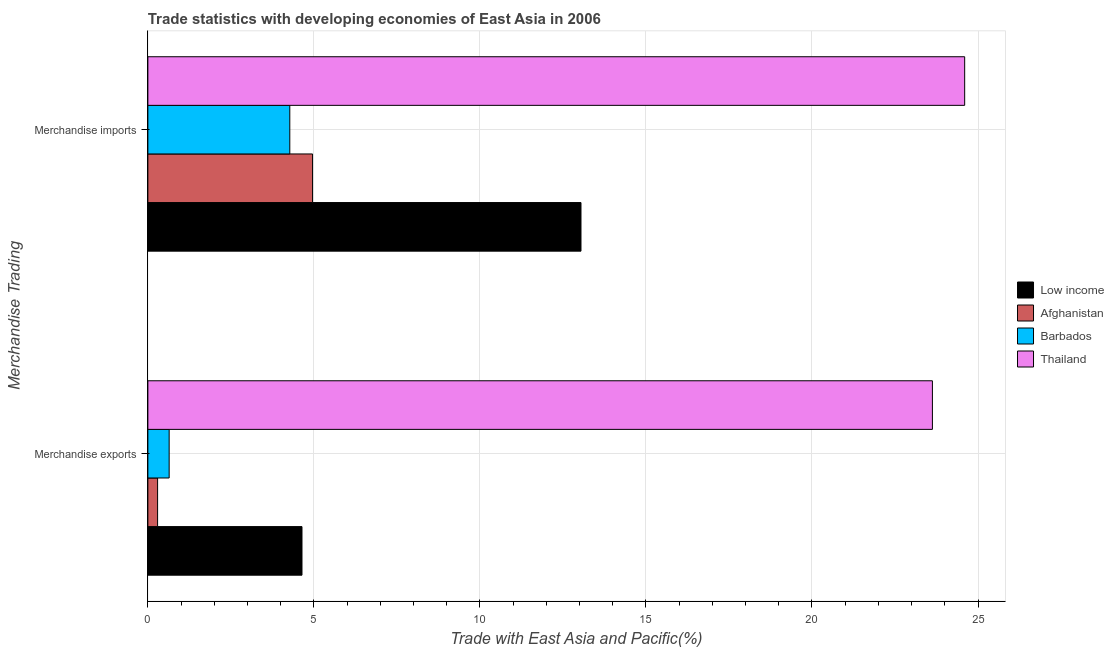Are the number of bars per tick equal to the number of legend labels?
Ensure brevity in your answer.  Yes. What is the merchandise imports in Afghanistan?
Your response must be concise. 4.96. Across all countries, what is the maximum merchandise exports?
Your response must be concise. 23.63. Across all countries, what is the minimum merchandise exports?
Your answer should be very brief. 0.29. In which country was the merchandise exports maximum?
Offer a very short reply. Thailand. In which country was the merchandise imports minimum?
Keep it short and to the point. Barbados. What is the total merchandise exports in the graph?
Provide a succinct answer. 29.2. What is the difference between the merchandise exports in Barbados and that in Low income?
Your response must be concise. -4. What is the difference between the merchandise exports in Low income and the merchandise imports in Afghanistan?
Provide a short and direct response. -0.32. What is the average merchandise imports per country?
Provide a succinct answer. 11.72. What is the difference between the merchandise imports and merchandise exports in Low income?
Provide a short and direct response. 8.4. What is the ratio of the merchandise imports in Afghanistan to that in Thailand?
Your answer should be compact. 0.2. Is the merchandise imports in Afghanistan less than that in Thailand?
Your answer should be very brief. Yes. What does the 1st bar from the top in Merchandise exports represents?
Your response must be concise. Thailand. What does the 1st bar from the bottom in Merchandise exports represents?
Offer a very short reply. Low income. Are the values on the major ticks of X-axis written in scientific E-notation?
Your answer should be compact. No. How many legend labels are there?
Your response must be concise. 4. What is the title of the graph?
Offer a very short reply. Trade statistics with developing economies of East Asia in 2006. Does "Ethiopia" appear as one of the legend labels in the graph?
Your answer should be compact. No. What is the label or title of the X-axis?
Your answer should be compact. Trade with East Asia and Pacific(%). What is the label or title of the Y-axis?
Give a very brief answer. Merchandise Trading. What is the Trade with East Asia and Pacific(%) in Low income in Merchandise exports?
Your response must be concise. 4.64. What is the Trade with East Asia and Pacific(%) of Afghanistan in Merchandise exports?
Offer a very short reply. 0.29. What is the Trade with East Asia and Pacific(%) in Barbados in Merchandise exports?
Your response must be concise. 0.64. What is the Trade with East Asia and Pacific(%) of Thailand in Merchandise exports?
Offer a terse response. 23.63. What is the Trade with East Asia and Pacific(%) in Low income in Merchandise imports?
Offer a very short reply. 13.04. What is the Trade with East Asia and Pacific(%) of Afghanistan in Merchandise imports?
Give a very brief answer. 4.96. What is the Trade with East Asia and Pacific(%) of Barbados in Merchandise imports?
Make the answer very short. 4.27. What is the Trade with East Asia and Pacific(%) of Thailand in Merchandise imports?
Offer a terse response. 24.6. Across all Merchandise Trading, what is the maximum Trade with East Asia and Pacific(%) of Low income?
Give a very brief answer. 13.04. Across all Merchandise Trading, what is the maximum Trade with East Asia and Pacific(%) in Afghanistan?
Your answer should be compact. 4.96. Across all Merchandise Trading, what is the maximum Trade with East Asia and Pacific(%) of Barbados?
Give a very brief answer. 4.27. Across all Merchandise Trading, what is the maximum Trade with East Asia and Pacific(%) in Thailand?
Offer a very short reply. 24.6. Across all Merchandise Trading, what is the minimum Trade with East Asia and Pacific(%) of Low income?
Your answer should be compact. 4.64. Across all Merchandise Trading, what is the minimum Trade with East Asia and Pacific(%) in Afghanistan?
Keep it short and to the point. 0.29. Across all Merchandise Trading, what is the minimum Trade with East Asia and Pacific(%) in Barbados?
Your answer should be very brief. 0.64. Across all Merchandise Trading, what is the minimum Trade with East Asia and Pacific(%) in Thailand?
Give a very brief answer. 23.63. What is the total Trade with East Asia and Pacific(%) in Low income in the graph?
Your answer should be very brief. 17.69. What is the total Trade with East Asia and Pacific(%) in Afghanistan in the graph?
Keep it short and to the point. 5.25. What is the total Trade with East Asia and Pacific(%) in Barbados in the graph?
Provide a succinct answer. 4.92. What is the total Trade with East Asia and Pacific(%) of Thailand in the graph?
Ensure brevity in your answer.  48.23. What is the difference between the Trade with East Asia and Pacific(%) in Low income in Merchandise exports and that in Merchandise imports?
Your answer should be very brief. -8.4. What is the difference between the Trade with East Asia and Pacific(%) of Afghanistan in Merchandise exports and that in Merchandise imports?
Offer a terse response. -4.67. What is the difference between the Trade with East Asia and Pacific(%) of Barbados in Merchandise exports and that in Merchandise imports?
Provide a succinct answer. -3.63. What is the difference between the Trade with East Asia and Pacific(%) of Thailand in Merchandise exports and that in Merchandise imports?
Give a very brief answer. -0.97. What is the difference between the Trade with East Asia and Pacific(%) in Low income in Merchandise exports and the Trade with East Asia and Pacific(%) in Afghanistan in Merchandise imports?
Provide a succinct answer. -0.32. What is the difference between the Trade with East Asia and Pacific(%) of Low income in Merchandise exports and the Trade with East Asia and Pacific(%) of Barbados in Merchandise imports?
Offer a terse response. 0.37. What is the difference between the Trade with East Asia and Pacific(%) of Low income in Merchandise exports and the Trade with East Asia and Pacific(%) of Thailand in Merchandise imports?
Offer a terse response. -19.96. What is the difference between the Trade with East Asia and Pacific(%) in Afghanistan in Merchandise exports and the Trade with East Asia and Pacific(%) in Barbados in Merchandise imports?
Offer a terse response. -3.98. What is the difference between the Trade with East Asia and Pacific(%) in Afghanistan in Merchandise exports and the Trade with East Asia and Pacific(%) in Thailand in Merchandise imports?
Keep it short and to the point. -24.31. What is the difference between the Trade with East Asia and Pacific(%) of Barbados in Merchandise exports and the Trade with East Asia and Pacific(%) of Thailand in Merchandise imports?
Offer a terse response. -23.96. What is the average Trade with East Asia and Pacific(%) of Low income per Merchandise Trading?
Your answer should be compact. 8.84. What is the average Trade with East Asia and Pacific(%) in Afghanistan per Merchandise Trading?
Your answer should be compact. 2.63. What is the average Trade with East Asia and Pacific(%) of Barbados per Merchandise Trading?
Your answer should be compact. 2.46. What is the average Trade with East Asia and Pacific(%) of Thailand per Merchandise Trading?
Your response must be concise. 24.11. What is the difference between the Trade with East Asia and Pacific(%) of Low income and Trade with East Asia and Pacific(%) of Afghanistan in Merchandise exports?
Offer a terse response. 4.35. What is the difference between the Trade with East Asia and Pacific(%) of Low income and Trade with East Asia and Pacific(%) of Barbados in Merchandise exports?
Offer a very short reply. 4. What is the difference between the Trade with East Asia and Pacific(%) of Low income and Trade with East Asia and Pacific(%) of Thailand in Merchandise exports?
Your response must be concise. -18.99. What is the difference between the Trade with East Asia and Pacific(%) of Afghanistan and Trade with East Asia and Pacific(%) of Barbados in Merchandise exports?
Offer a terse response. -0.35. What is the difference between the Trade with East Asia and Pacific(%) of Afghanistan and Trade with East Asia and Pacific(%) of Thailand in Merchandise exports?
Offer a terse response. -23.33. What is the difference between the Trade with East Asia and Pacific(%) of Barbados and Trade with East Asia and Pacific(%) of Thailand in Merchandise exports?
Your response must be concise. -22.99. What is the difference between the Trade with East Asia and Pacific(%) of Low income and Trade with East Asia and Pacific(%) of Afghanistan in Merchandise imports?
Your response must be concise. 8.08. What is the difference between the Trade with East Asia and Pacific(%) in Low income and Trade with East Asia and Pacific(%) in Barbados in Merchandise imports?
Your response must be concise. 8.77. What is the difference between the Trade with East Asia and Pacific(%) of Low income and Trade with East Asia and Pacific(%) of Thailand in Merchandise imports?
Give a very brief answer. -11.55. What is the difference between the Trade with East Asia and Pacific(%) in Afghanistan and Trade with East Asia and Pacific(%) in Barbados in Merchandise imports?
Ensure brevity in your answer.  0.68. What is the difference between the Trade with East Asia and Pacific(%) of Afghanistan and Trade with East Asia and Pacific(%) of Thailand in Merchandise imports?
Offer a terse response. -19.64. What is the difference between the Trade with East Asia and Pacific(%) of Barbados and Trade with East Asia and Pacific(%) of Thailand in Merchandise imports?
Provide a short and direct response. -20.32. What is the ratio of the Trade with East Asia and Pacific(%) in Low income in Merchandise exports to that in Merchandise imports?
Offer a very short reply. 0.36. What is the ratio of the Trade with East Asia and Pacific(%) in Afghanistan in Merchandise exports to that in Merchandise imports?
Provide a succinct answer. 0.06. What is the ratio of the Trade with East Asia and Pacific(%) in Barbados in Merchandise exports to that in Merchandise imports?
Keep it short and to the point. 0.15. What is the ratio of the Trade with East Asia and Pacific(%) of Thailand in Merchandise exports to that in Merchandise imports?
Ensure brevity in your answer.  0.96. What is the difference between the highest and the second highest Trade with East Asia and Pacific(%) of Low income?
Provide a succinct answer. 8.4. What is the difference between the highest and the second highest Trade with East Asia and Pacific(%) of Afghanistan?
Offer a terse response. 4.67. What is the difference between the highest and the second highest Trade with East Asia and Pacific(%) in Barbados?
Give a very brief answer. 3.63. What is the difference between the highest and the second highest Trade with East Asia and Pacific(%) of Thailand?
Provide a succinct answer. 0.97. What is the difference between the highest and the lowest Trade with East Asia and Pacific(%) of Low income?
Your response must be concise. 8.4. What is the difference between the highest and the lowest Trade with East Asia and Pacific(%) of Afghanistan?
Provide a succinct answer. 4.67. What is the difference between the highest and the lowest Trade with East Asia and Pacific(%) of Barbados?
Provide a succinct answer. 3.63. What is the difference between the highest and the lowest Trade with East Asia and Pacific(%) of Thailand?
Ensure brevity in your answer.  0.97. 